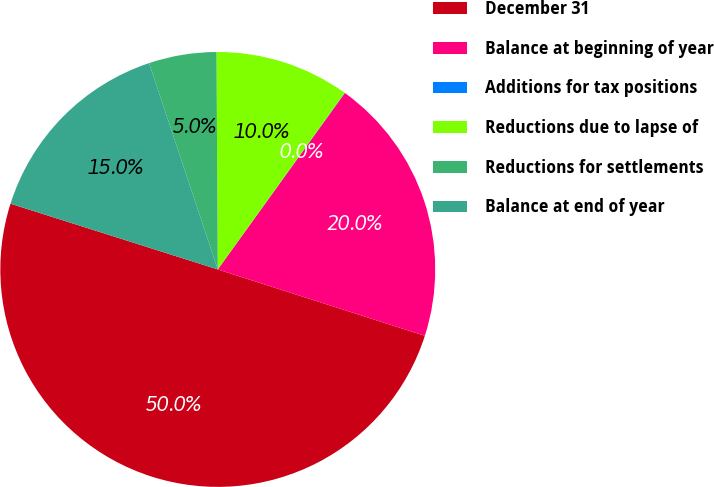Convert chart. <chart><loc_0><loc_0><loc_500><loc_500><pie_chart><fcel>December 31<fcel>Balance at beginning of year<fcel>Additions for tax positions<fcel>Reductions due to lapse of<fcel>Reductions for settlements<fcel>Balance at end of year<nl><fcel>49.95%<fcel>20.0%<fcel>0.02%<fcel>10.01%<fcel>5.02%<fcel>15.0%<nl></chart> 